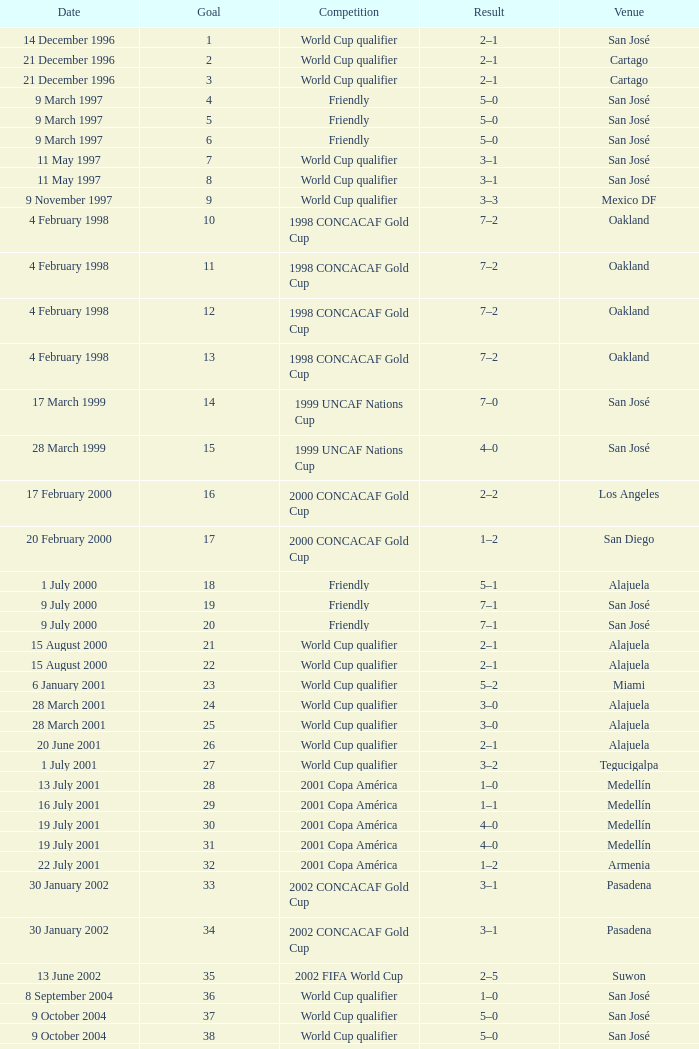What is the result in oakland? 7–2, 7–2, 7–2, 7–2. 